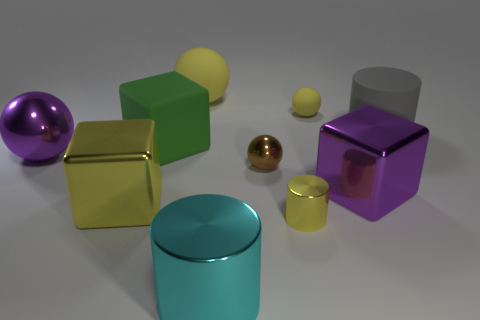Is the color of the metal block to the right of the big cyan metallic thing the same as the cylinder that is on the left side of the small yellow shiny cylinder?
Keep it short and to the point. No. What size is the purple object that is the same shape as the green matte thing?
Offer a terse response. Large. Is the material of the yellow ball that is in front of the big yellow rubber sphere the same as the big purple thing that is right of the big cyan metal thing?
Your answer should be compact. No. What number of metal things are either big purple cubes or large green cubes?
Make the answer very short. 1. The big cylinder behind the big cylinder in front of the metal block that is to the left of the large green rubber block is made of what material?
Provide a short and direct response. Rubber. There is a big rubber object that is behind the gray object; does it have the same shape as the small yellow thing behind the large gray matte cylinder?
Make the answer very short. Yes. There is a small ball that is behind the large matte thing that is in front of the large gray rubber thing; what color is it?
Your response must be concise. Yellow. How many blocks are either yellow rubber things or small shiny objects?
Keep it short and to the point. 0. What number of tiny objects are to the left of the shiny block that is on the left side of the small object that is in front of the large purple cube?
Provide a short and direct response. 0. What is the size of the ball that is the same color as the tiny matte object?
Provide a short and direct response. Large. 